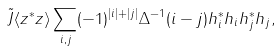Convert formula to latex. <formula><loc_0><loc_0><loc_500><loc_500>\tilde { J } \langle z ^ { * } z \rangle \sum _ { i , j } ( - 1 ) ^ { | i | + | j | } \Delta ^ { - 1 } ( i - j ) h ^ { * } _ { i } h _ { i } h ^ { * } _ { j } h _ { j } ,</formula> 